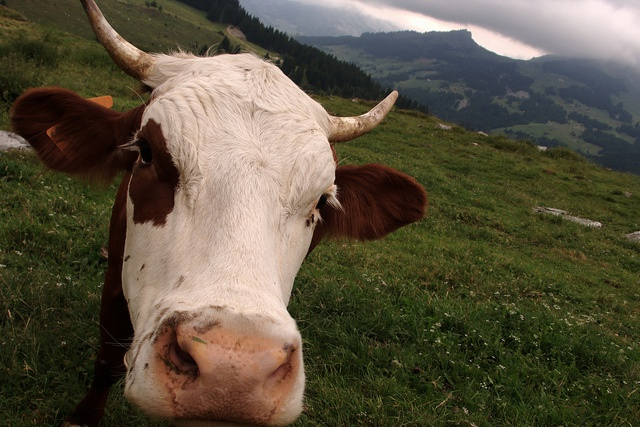Describe the objects in this image and their specific colors. I can see a cow in black, tan, and lightgray tones in this image. 